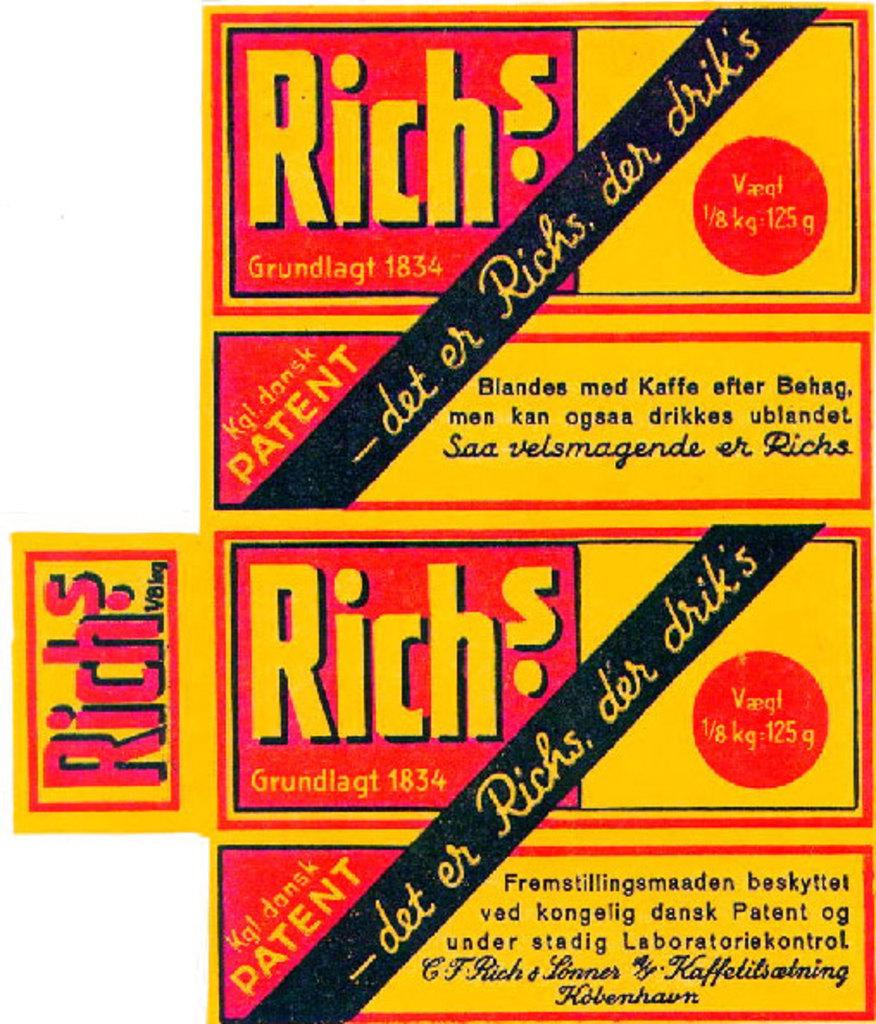What is present in the picture? There is a poster in the picture. What can be found on the poster? Words and numbers are written on the poster. What color is the background of the poster? The background of the poster is white. What type of hat is depicted on the poster? There is no hat present on the poster; it only contains words and numbers on a white background. 